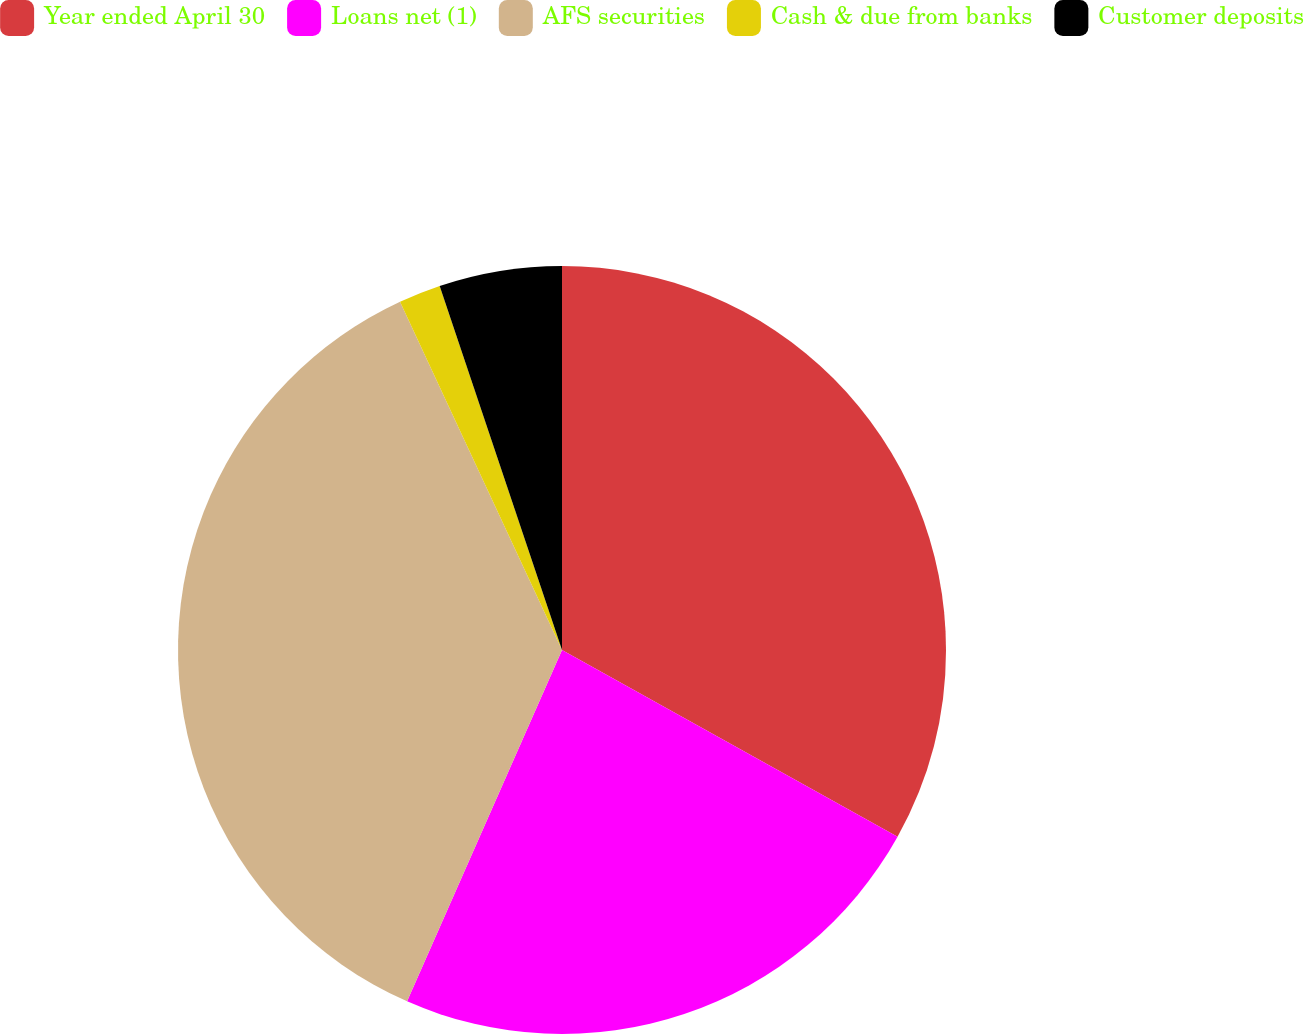Convert chart to OTSL. <chart><loc_0><loc_0><loc_500><loc_500><pie_chart><fcel>Year ended April 30<fcel>Loans net (1)<fcel>AFS securities<fcel>Cash & due from banks<fcel>Customer deposits<nl><fcel>33.08%<fcel>23.53%<fcel>36.46%<fcel>1.77%<fcel>5.16%<nl></chart> 